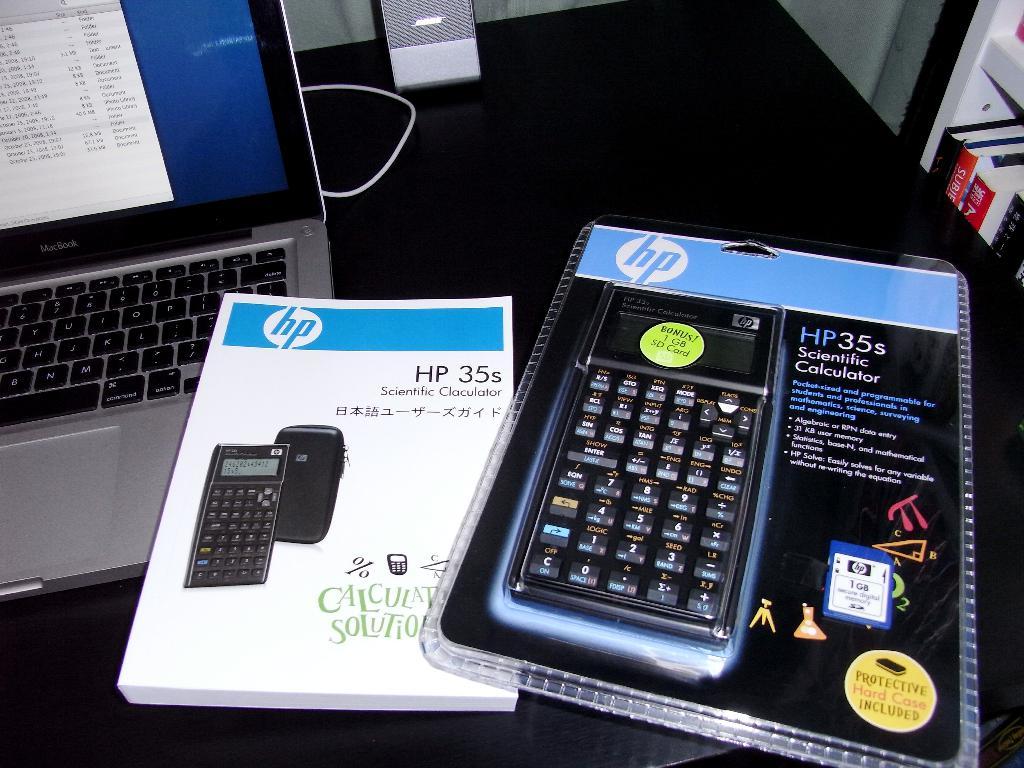What brand is this calculator?
Ensure brevity in your answer.  Hp. 